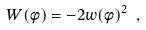Convert formula to latex. <formula><loc_0><loc_0><loc_500><loc_500>W ( \phi ) = - 2 w ( \phi ) ^ { 2 } \ ,</formula> 